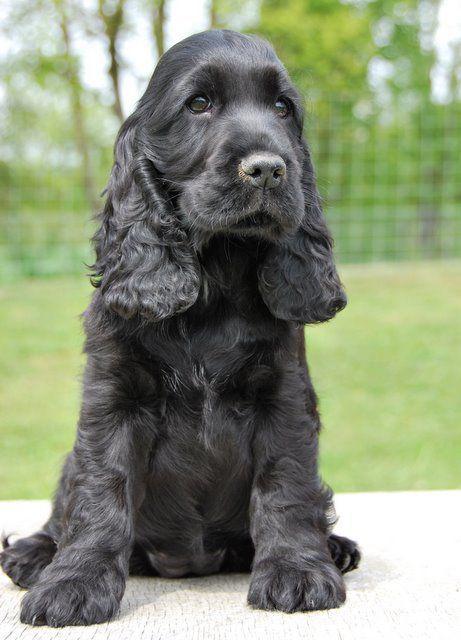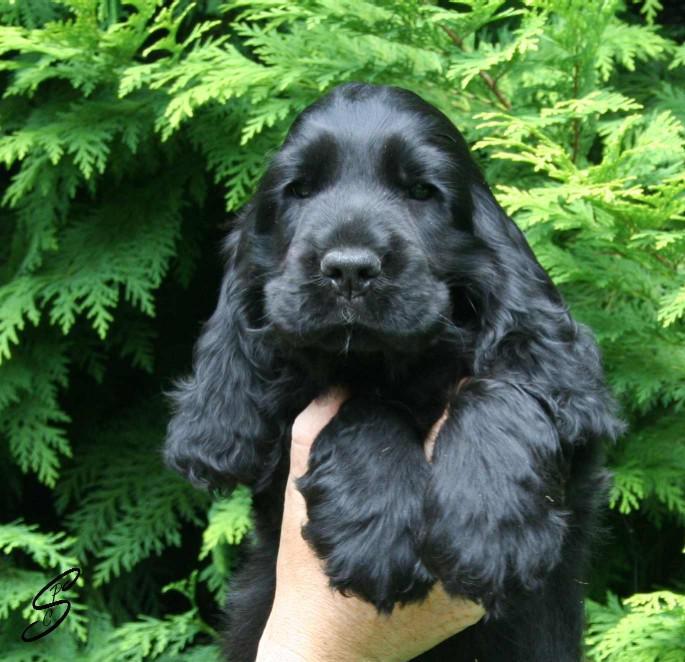The first image is the image on the left, the second image is the image on the right. Analyze the images presented: Is the assertion "There is a tan dog beside a black dog in one of the images." valid? Answer yes or no. No. The first image is the image on the left, the second image is the image on the right. Considering the images on both sides, is "An all black puppy and an all brown puppy are next to each other." valid? Answer yes or no. No. 